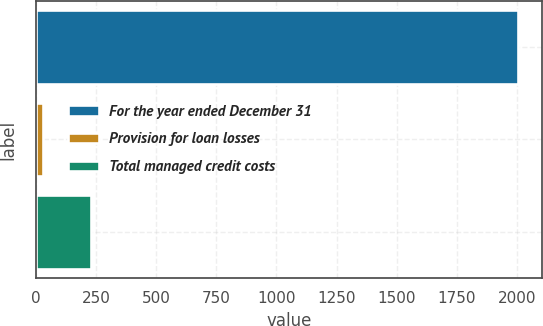<chart> <loc_0><loc_0><loc_500><loc_500><bar_chart><fcel>For the year ended December 31<fcel>Provision for loan losses<fcel>Total managed credit costs<nl><fcel>2003<fcel>30<fcel>227.3<nl></chart> 